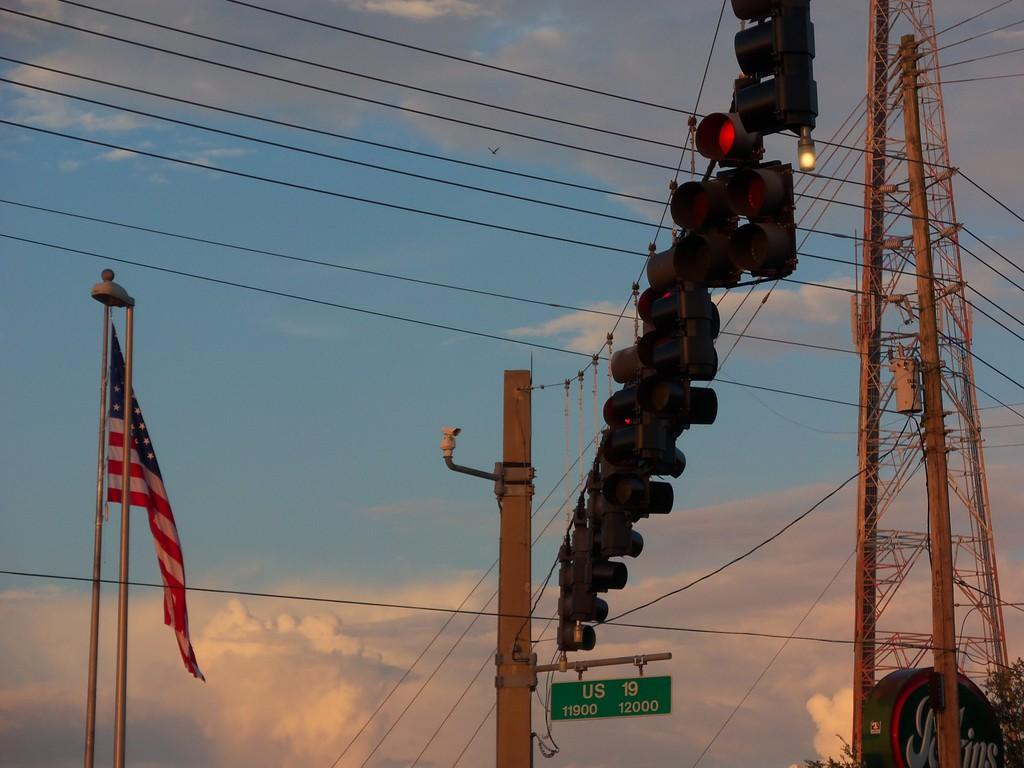<image>
Create a compact narrative representing the image presented. A flag and traffic lights are displayed along with the street sign US 19. 